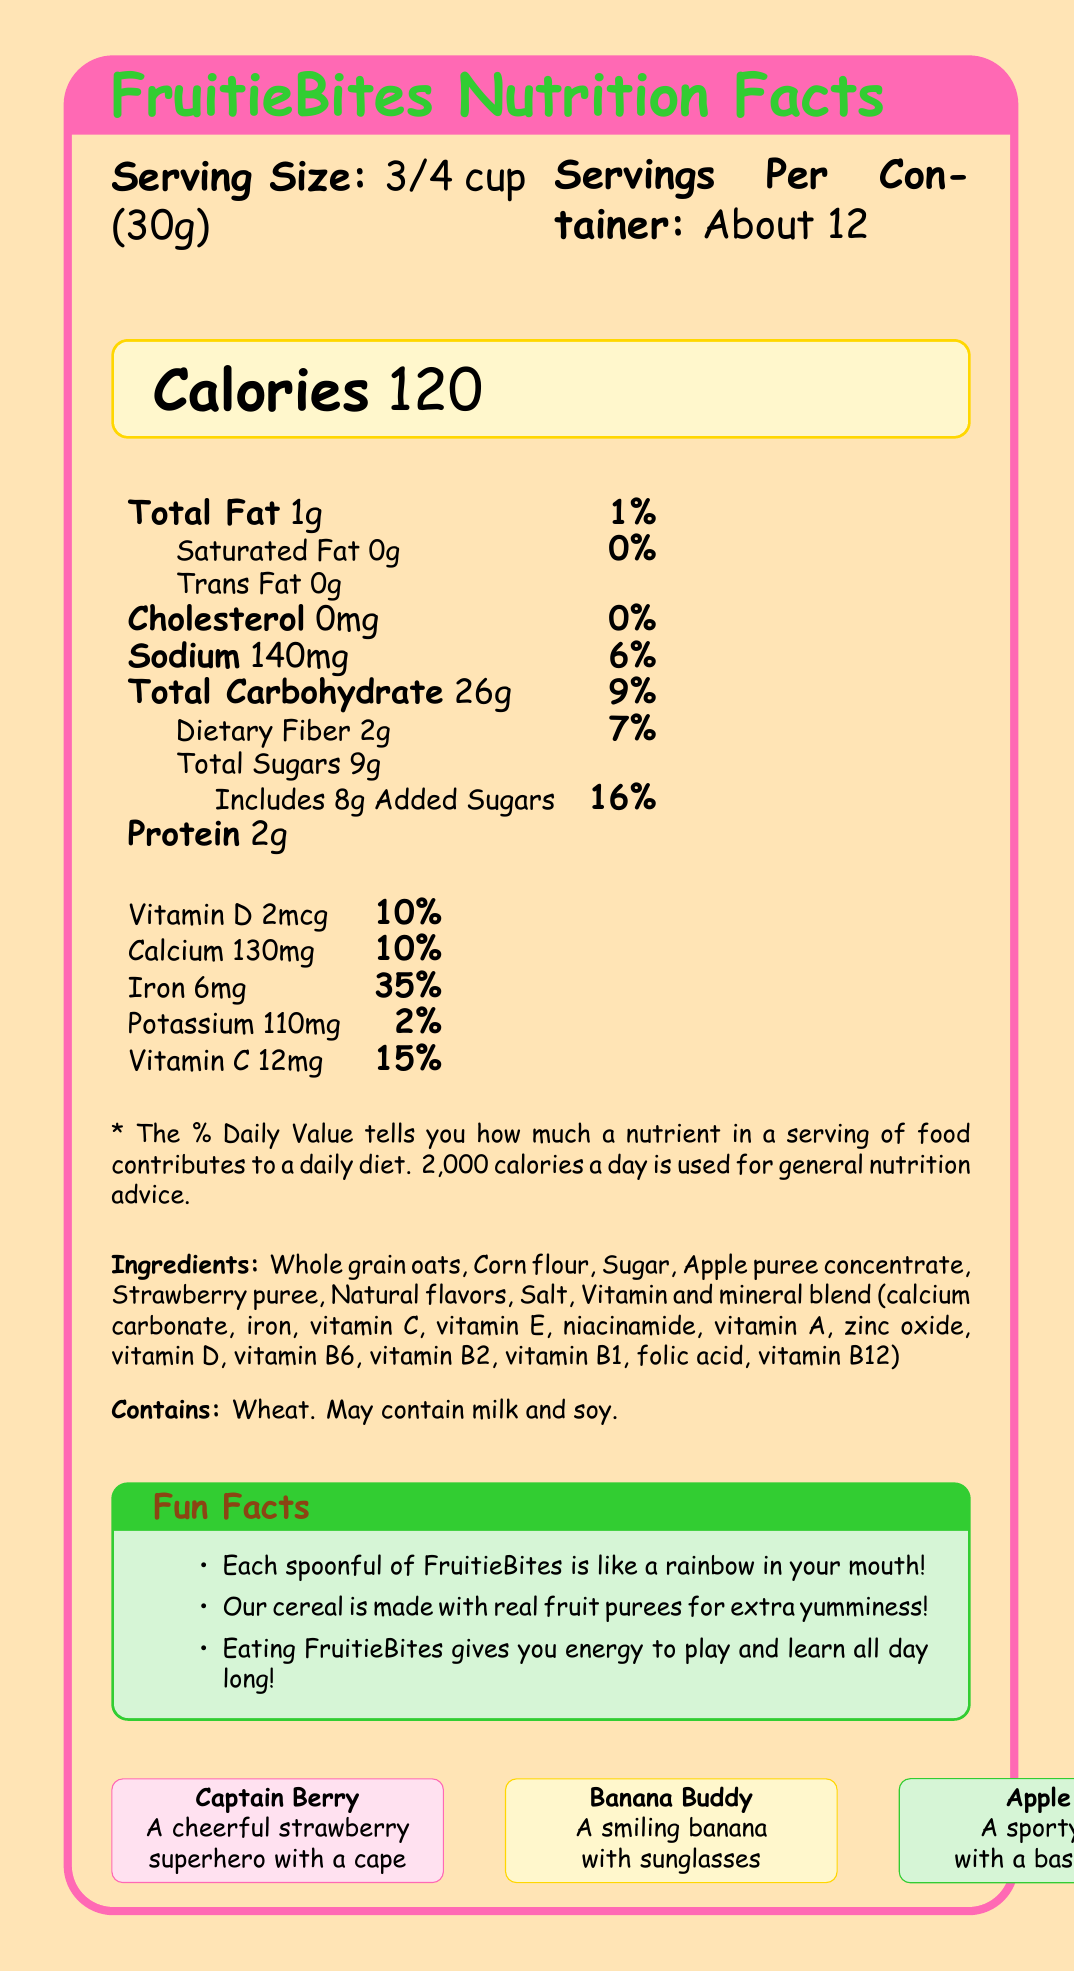What is the serving size of FruitieBites? The serving size is listed at the top of the nutrition facts label as "Serving Size: 3/4 cup (30g)".
Answer: 3/4 cup (30g) How many calories are in one serving of FruitieBites? The number of calories per serving is highlighted in the document section with a special box that says "Calories 120".
Answer: 120 How much iron is in a serving of FruitieBites as a percentage of the daily value? The amount of iron is indicated in the nutrition facts section where it lists "Iron 6mg 35%".
Answer: 35% What are the names of the cartoon characters on the FruitieBites box? The names of the cartoon characters are described along with their illustrations near the end of the document.
Answer: Captain Berry, Banana Buddy, and Apple Ace What is the fun fact about how each spoonful of FruitieBites tastes? This fun fact is found under the "Fun Facts" section in the document.
Answer: Each spoonful of FruitieBites is like a rainbow in your mouth! How many servings are there per container of FruitieBites? A. 10 B. About 12 C. 15 The number of servings per container is given near the top of the document as "Servings Per Container: About 12".
Answer: B. About 12 What is the total amount of sugars in one serving of FruitieBites? 1. 5g 2. 7g 3. 9g 4. 12g The total amount of sugars is listed under "Total Sugars" in the nutrition section as "9g".
Answer: 3. 9g Does FruitieBites contain any trans fat? The nutrition label specifically lists "Trans Fat 0g."
Answer: No What cartoon character is described as a cheerful strawberry superhero with a cape? This description is given in the section listing the cartoon characters, particularly for Captain Berry.
Answer: Captain Berry Does FruitieBites contain any milk or soy? The allergen information section mentions "May contain milk and soy."
Answer: May contain milk and soy What are the main nutrients highlighted in the nutrition facts label and their daily values? These nutrients and their daily values are detailed in the nutrition facts section.
Answer: Calories, Total Fat, Saturated Fat, Trans Fat, Cholesterol, Sodium, Total Carbohydrate, Dietary Fiber, Total Sugars, Protein, Vitamin D, Calcium, Iron, Potassium, and Vitamin C How much protein is there in one serving of FruitieBites? The protein amount is listed clearly in the nutrition facts section as "Protein 2g."
Answer: 2g How does the document describe the benefit of eating FruitieBites for kids? This benefit is stated in the "Fun Facts" section.
Answer: Eating FruitieBites gives you energy to play and learn all day long! What are some game ideas mentioned in the document that you can play with FruitieBites? These game ideas are listed in the document under "Game Ideas."
Answer: Count the different fruit shapes in your bowl, try to make a smiley face with your cereal pieces, and learn about colors by sorting the different colored pieces Can FruitieBites be used to make cookies? The document does not contain any information regarding making cookies with FruitieBites.
Answer: Cannot be determined Summarize the main features and information presented in the document. This summary encompasses the various sections of the document including nutritional data, ingredients, fun facts, game ideas, and character descriptions, thereby integrating all crucial elements presented visually.
Answer: The document provides the nutrition facts for FruitieBites, a fruit-flavored cereal featuring fun cartoon characters and colorful design elements. It lists nutritional information like calories, fats, carbohydrates, proteins, vitamins, and minerals. Ingredients and allergens are also detailed. Additionally, there are fun facts, game ideas, and descriptions of the cartoon characters to engage children. 